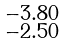<formula> <loc_0><loc_0><loc_500><loc_500>\begin{smallmatrix} - 3 . 8 0 \\ - 2 . 5 0 \end{smallmatrix}</formula> 